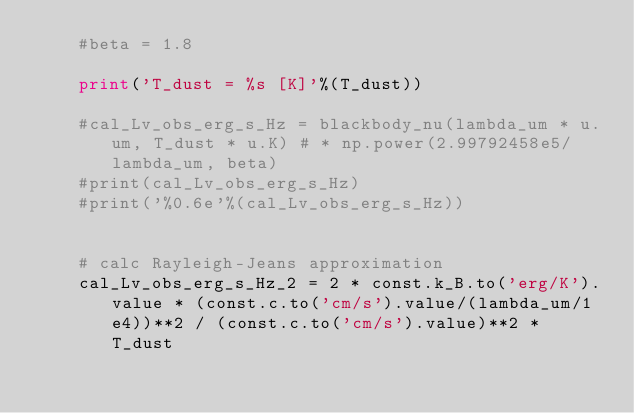<code> <loc_0><loc_0><loc_500><loc_500><_Python_>    #beta = 1.8
    
    print('T_dust = %s [K]'%(T_dust))
    
    #cal_Lv_obs_erg_s_Hz = blackbody_nu(lambda_um * u.um, T_dust * u.K) # * np.power(2.99792458e5/lambda_um, beta)
    #print(cal_Lv_obs_erg_s_Hz)
    #print('%0.6e'%(cal_Lv_obs_erg_s_Hz))
    
    
    # calc Rayleigh-Jeans approximation
    cal_Lv_obs_erg_s_Hz_2 = 2 * const.k_B.to('erg/K').value * (const.c.to('cm/s').value/(lambda_um/1e4))**2 / (const.c.to('cm/s').value)**2 * T_dust</code> 